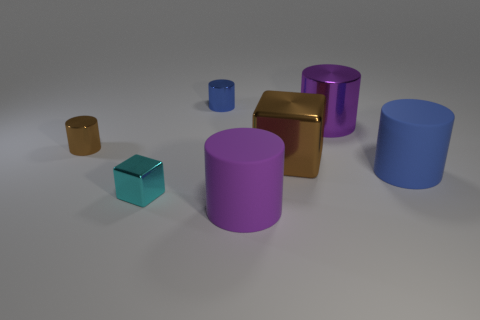There is a matte thing that is the same color as the big shiny cylinder; what is its shape?
Provide a short and direct response. Cylinder. There is a metal thing that is the same color as the large shiny cube; what is its size?
Your response must be concise. Small. Does the tiny blue object have the same shape as the brown metal thing that is to the left of the large brown metallic object?
Give a very brief answer. Yes. How many other things are the same shape as the purple rubber thing?
Your answer should be compact. 4. How many things are tiny gray matte cylinders or small brown cylinders?
Offer a terse response. 1. Is the color of the tiny metal cube the same as the big shiny cylinder?
Give a very brief answer. No. There is a brown metallic thing that is on the right side of the large rubber cylinder to the left of the purple metal thing; what is its shape?
Offer a terse response. Cube. Is the number of big cyan cylinders less than the number of large purple matte objects?
Your answer should be compact. Yes. There is a metal thing that is to the left of the tiny blue thing and behind the tiny cyan metal thing; what size is it?
Provide a short and direct response. Small. Does the blue metallic object have the same size as the purple rubber cylinder?
Provide a succinct answer. No. 